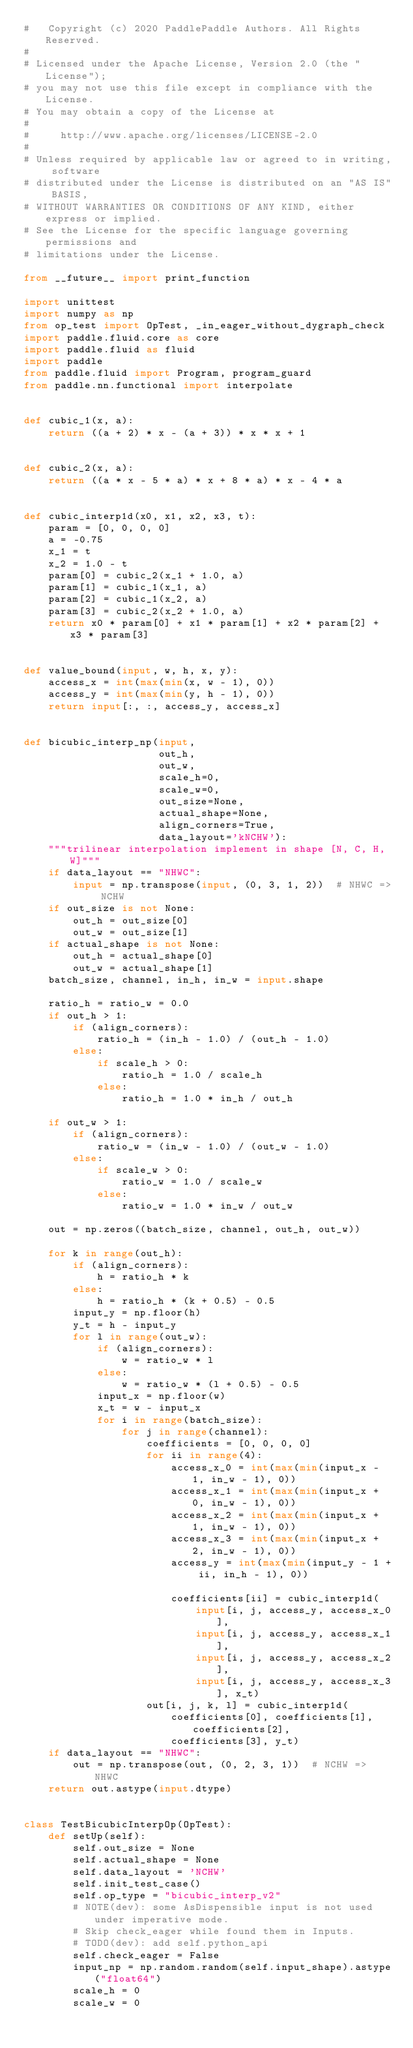<code> <loc_0><loc_0><loc_500><loc_500><_Python_>#   Copyright (c) 2020 PaddlePaddle Authors. All Rights Reserved.
#
# Licensed under the Apache License, Version 2.0 (the "License");
# you may not use this file except in compliance with the License.
# You may obtain a copy of the License at
#
#     http://www.apache.org/licenses/LICENSE-2.0
#
# Unless required by applicable law or agreed to in writing, software
# distributed under the License is distributed on an "AS IS" BASIS,
# WITHOUT WARRANTIES OR CONDITIONS OF ANY KIND, either express or implied.
# See the License for the specific language governing permissions and
# limitations under the License.

from __future__ import print_function

import unittest
import numpy as np
from op_test import OpTest, _in_eager_without_dygraph_check
import paddle.fluid.core as core
import paddle.fluid as fluid
import paddle
from paddle.fluid import Program, program_guard
from paddle.nn.functional import interpolate


def cubic_1(x, a):
    return ((a + 2) * x - (a + 3)) * x * x + 1


def cubic_2(x, a):
    return ((a * x - 5 * a) * x + 8 * a) * x - 4 * a


def cubic_interp1d(x0, x1, x2, x3, t):
    param = [0, 0, 0, 0]
    a = -0.75
    x_1 = t
    x_2 = 1.0 - t
    param[0] = cubic_2(x_1 + 1.0, a)
    param[1] = cubic_1(x_1, a)
    param[2] = cubic_1(x_2, a)
    param[3] = cubic_2(x_2 + 1.0, a)
    return x0 * param[0] + x1 * param[1] + x2 * param[2] + x3 * param[3]


def value_bound(input, w, h, x, y):
    access_x = int(max(min(x, w - 1), 0))
    access_y = int(max(min(y, h - 1), 0))
    return input[:, :, access_y, access_x]


def bicubic_interp_np(input,
                      out_h,
                      out_w,
                      scale_h=0,
                      scale_w=0,
                      out_size=None,
                      actual_shape=None,
                      align_corners=True,
                      data_layout='kNCHW'):
    """trilinear interpolation implement in shape [N, C, H, W]"""
    if data_layout == "NHWC":
        input = np.transpose(input, (0, 3, 1, 2))  # NHWC => NCHW
    if out_size is not None:
        out_h = out_size[0]
        out_w = out_size[1]
    if actual_shape is not None:
        out_h = actual_shape[0]
        out_w = actual_shape[1]
    batch_size, channel, in_h, in_w = input.shape

    ratio_h = ratio_w = 0.0
    if out_h > 1:
        if (align_corners):
            ratio_h = (in_h - 1.0) / (out_h - 1.0)
        else:
            if scale_h > 0:
                ratio_h = 1.0 / scale_h
            else:
                ratio_h = 1.0 * in_h / out_h

    if out_w > 1:
        if (align_corners):
            ratio_w = (in_w - 1.0) / (out_w - 1.0)
        else:
            if scale_w > 0:
                ratio_w = 1.0 / scale_w
            else:
                ratio_w = 1.0 * in_w / out_w

    out = np.zeros((batch_size, channel, out_h, out_w))

    for k in range(out_h):
        if (align_corners):
            h = ratio_h * k
        else:
            h = ratio_h * (k + 0.5) - 0.5
        input_y = np.floor(h)
        y_t = h - input_y
        for l in range(out_w):
            if (align_corners):
                w = ratio_w * l
            else:
                w = ratio_w * (l + 0.5) - 0.5
            input_x = np.floor(w)
            x_t = w - input_x
            for i in range(batch_size):
                for j in range(channel):
                    coefficients = [0, 0, 0, 0]
                    for ii in range(4):
                        access_x_0 = int(max(min(input_x - 1, in_w - 1), 0))
                        access_x_1 = int(max(min(input_x + 0, in_w - 1), 0))
                        access_x_2 = int(max(min(input_x + 1, in_w - 1), 0))
                        access_x_3 = int(max(min(input_x + 2, in_w - 1), 0))
                        access_y = int(max(min(input_y - 1 + ii, in_h - 1), 0))

                        coefficients[ii] = cubic_interp1d(
                            input[i, j, access_y, access_x_0],
                            input[i, j, access_y, access_x_1],
                            input[i, j, access_y, access_x_2],
                            input[i, j, access_y, access_x_3], x_t)
                    out[i, j, k, l] = cubic_interp1d(
                        coefficients[0], coefficients[1], coefficients[2],
                        coefficients[3], y_t)
    if data_layout == "NHWC":
        out = np.transpose(out, (0, 2, 3, 1))  # NCHW => NHWC
    return out.astype(input.dtype)


class TestBicubicInterpOp(OpTest):
    def setUp(self):
        self.out_size = None
        self.actual_shape = None
        self.data_layout = 'NCHW'
        self.init_test_case()
        self.op_type = "bicubic_interp_v2"
        # NOTE(dev): some AsDispensible input is not used under imperative mode.
        # Skip check_eager while found them in Inputs.
        # TODO(dev): add self.python_api
        self.check_eager = False
        input_np = np.random.random(self.input_shape).astype("float64")
        scale_h = 0
        scale_w = 0</code> 